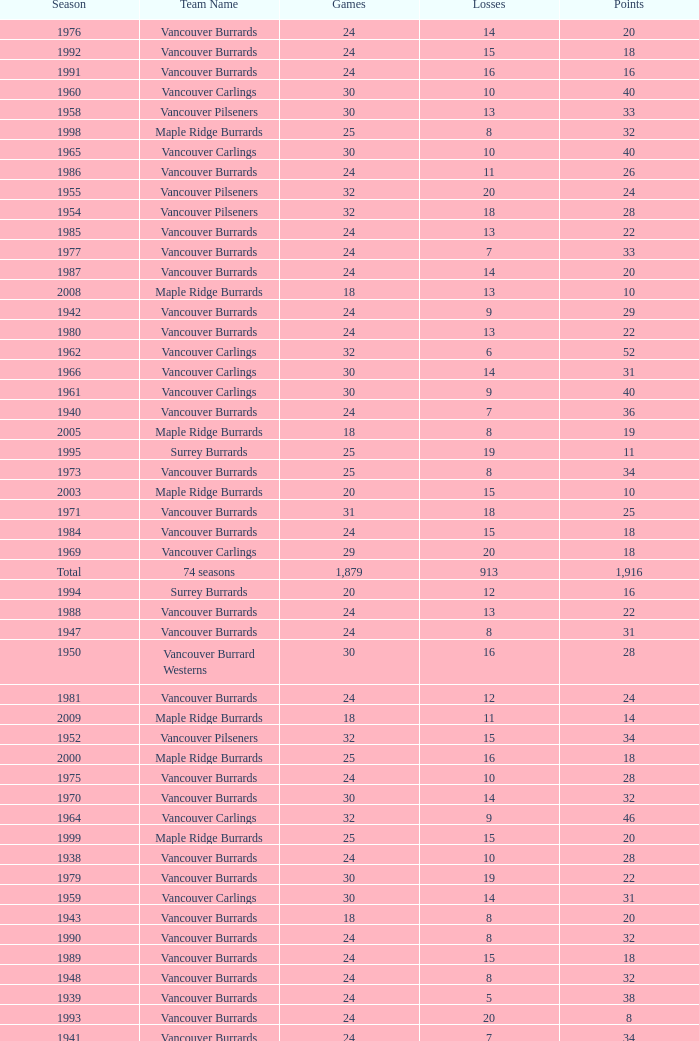What's the total number of points when the vancouver burrards have fewer than 9 losses and more than 24 games? 1.0. 